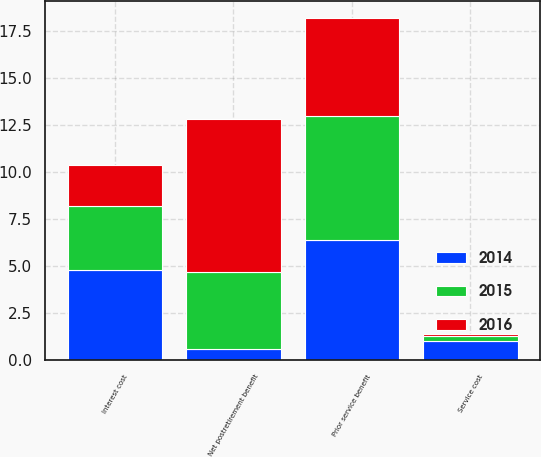Convert chart to OTSL. <chart><loc_0><loc_0><loc_500><loc_500><stacked_bar_chart><ecel><fcel>Service cost<fcel>Interest cost<fcel>Prior service benefit<fcel>Net postretirement benefit<nl><fcel>2016<fcel>0.1<fcel>2.2<fcel>5.2<fcel>8.1<nl><fcel>2015<fcel>0.3<fcel>3.4<fcel>6.6<fcel>4.1<nl><fcel>2014<fcel>1<fcel>4.8<fcel>6.4<fcel>0.6<nl></chart> 